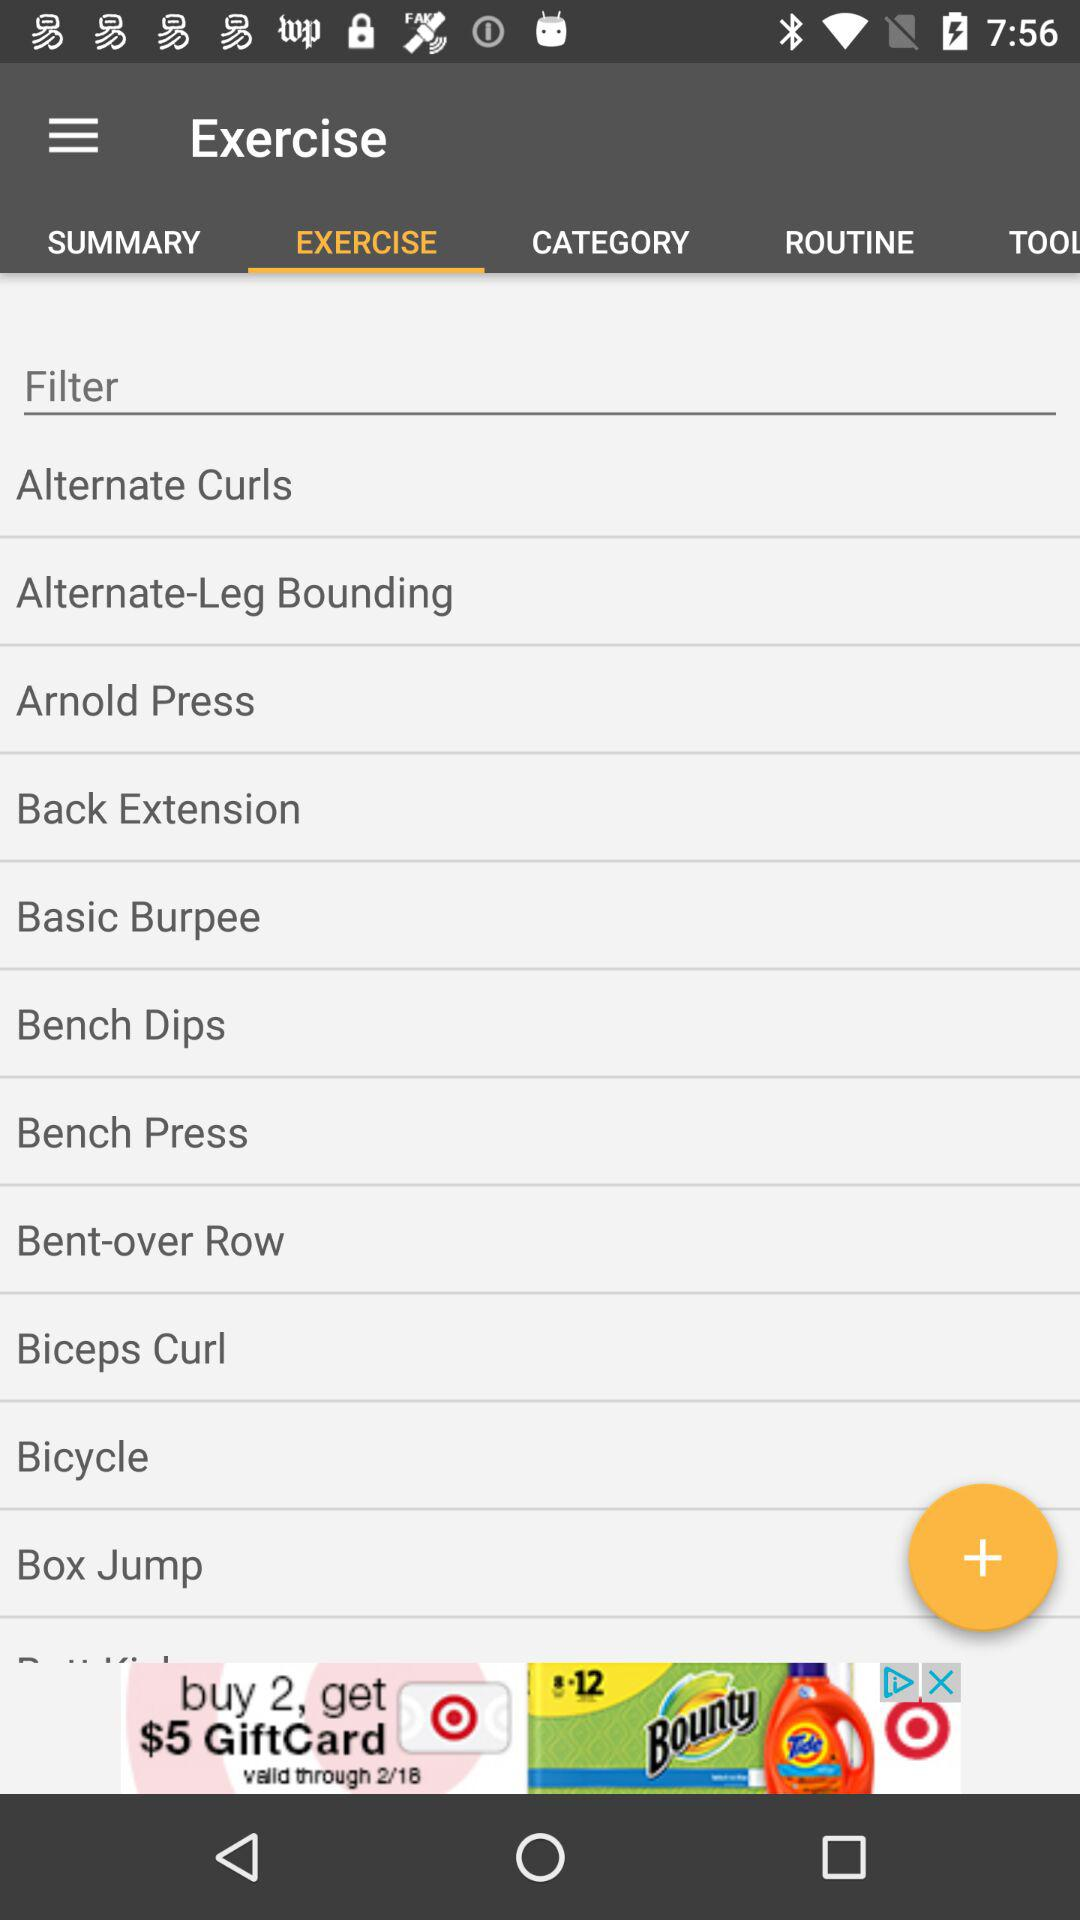What exercises are there? The exercises are "Alternate Curls", "Alternate-Leg Bounding", "Arnold Press", "Back Extension", "Basic Burpee", "Bench Dips", "Bench Press", "Bent-over Row", "Biceps Curl", "Bicycle" and "Box Jump". 